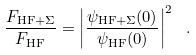Convert formula to latex. <formula><loc_0><loc_0><loc_500><loc_500>\frac { F _ { { \text {HF} } + \Sigma } } { F _ { \text {HF} } } = \left | \frac { \psi _ { { \text {HF} } + \Sigma } ( 0 ) } { \psi _ { \text {HF} } ( 0 ) } \right | ^ { 2 } \ .</formula> 